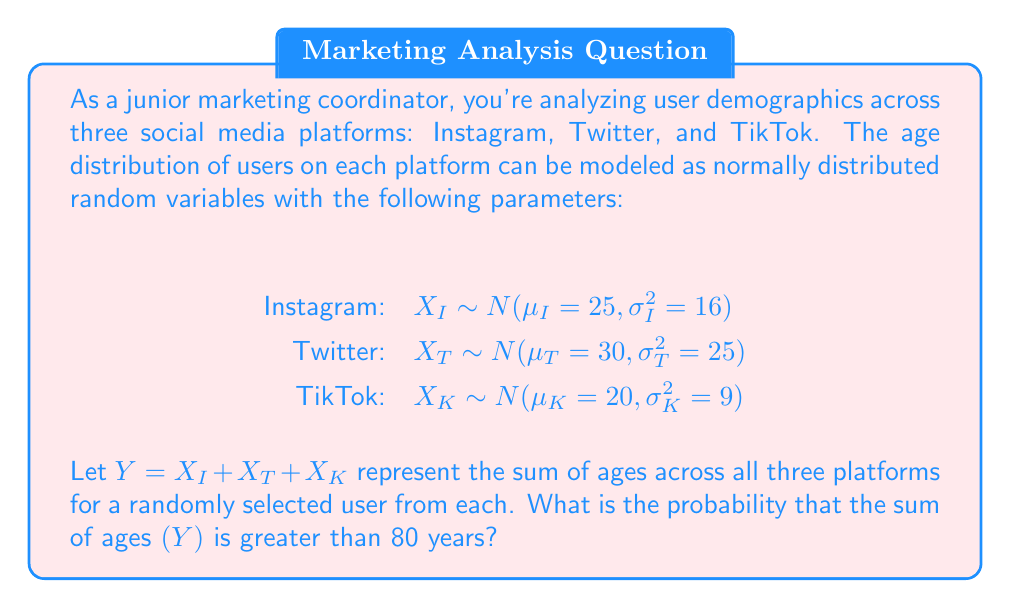Can you solve this math problem? To solve this problem, we'll follow these steps:

1) First, recall that the sum of independent normally distributed random variables is also normally distributed.

2) We need to find the mean and variance of Y:

   $\mu_Y = \mu_I + \mu_T + \mu_K = 25 + 30 + 20 = 75$

   $\sigma_Y^2 = \sigma_I^2 + \sigma_T^2 + \sigma_K^2 = 16 + 25 + 9 = 50$

3) Now we know that $Y \sim N(75, 50)$

4) We want to find $P(Y > 80)$

5) To standardize this, we calculate the z-score:

   $z = \frac{80 - \mu_Y}{\sigma_Y} = \frac{80 - 75}{\sqrt{50}} = \frac{5}{\sqrt{50}} = \frac{5}{7.071} \approx 0.707$

6) Now we need to find $P(Z > 0.707)$, where Z is the standard normal distribution.

7) Using a standard normal table or calculator, we find:

   $P(Z > 0.707) = 1 - P(Z < 0.707) = 1 - 0.7602 = 0.2398$

Therefore, the probability that the sum of ages is greater than 80 years is approximately 0.2398 or 23.98%.
Answer: 0.2398 